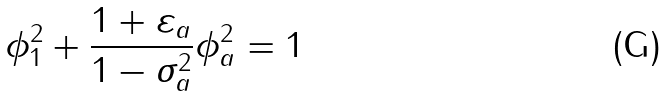Convert formula to latex. <formula><loc_0><loc_0><loc_500><loc_500>\phi _ { 1 } ^ { 2 } + \frac { 1 + \varepsilon _ { a } } { 1 - \sigma _ { a } ^ { 2 } } \phi _ { a } ^ { 2 } = 1</formula> 